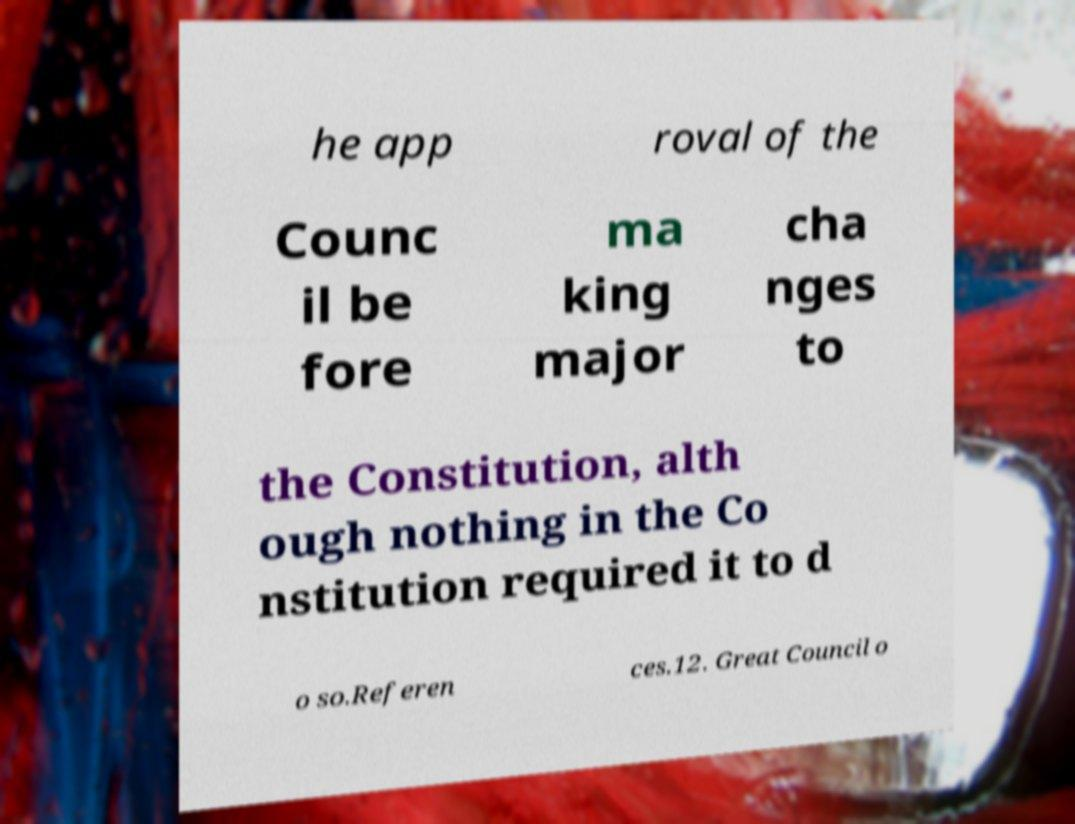Can you read and provide the text displayed in the image?This photo seems to have some interesting text. Can you extract and type it out for me? he app roval of the Counc il be fore ma king major cha nges to the Constitution, alth ough nothing in the Co nstitution required it to d o so.Referen ces.12. Great Council o 